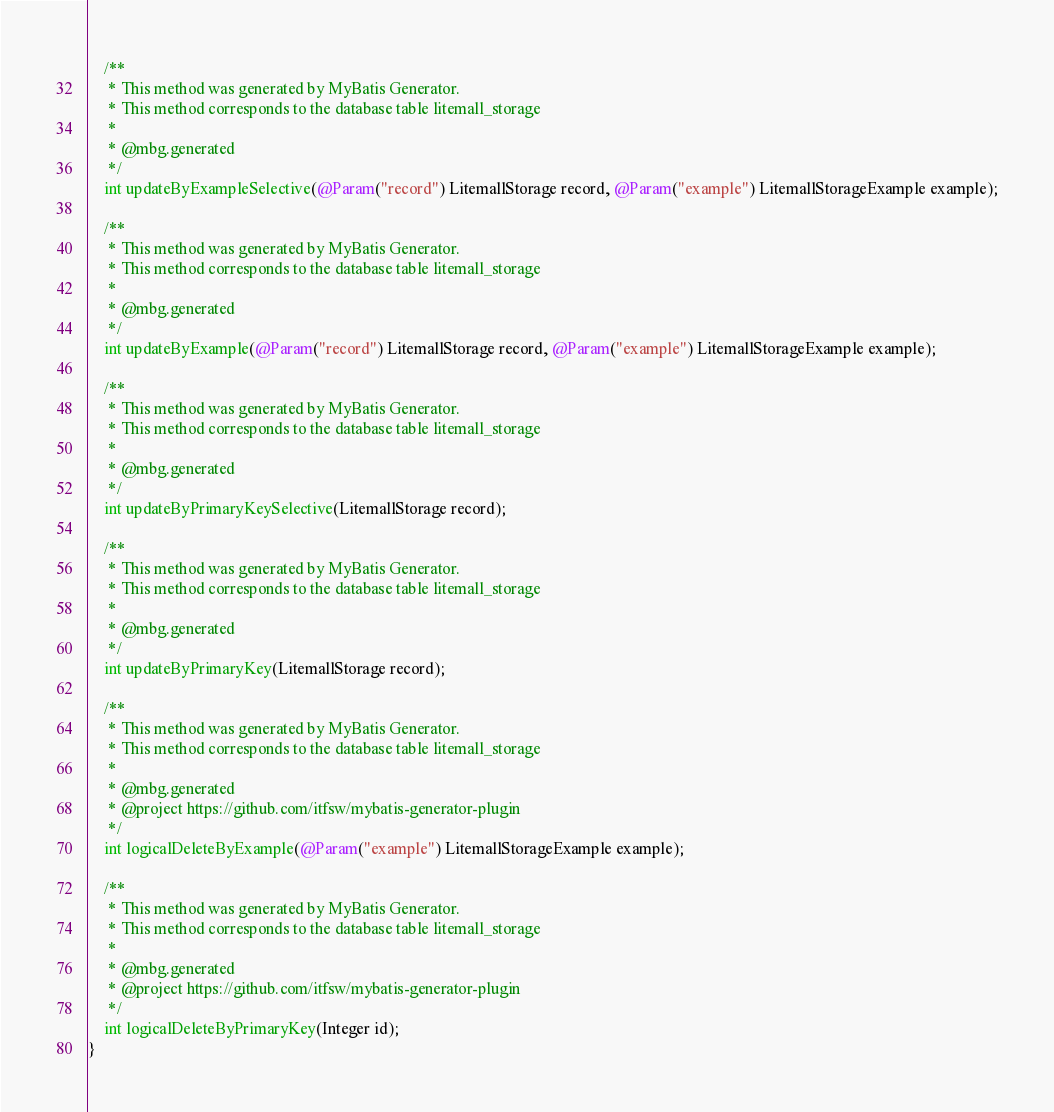<code> <loc_0><loc_0><loc_500><loc_500><_Java_>    /**
     * This method was generated by MyBatis Generator.
     * This method corresponds to the database table litemall_storage
     *
     * @mbg.generated
     */
    int updateByExampleSelective(@Param("record") LitemallStorage record, @Param("example") LitemallStorageExample example);

    /**
     * This method was generated by MyBatis Generator.
     * This method corresponds to the database table litemall_storage
     *
     * @mbg.generated
     */
    int updateByExample(@Param("record") LitemallStorage record, @Param("example") LitemallStorageExample example);

    /**
     * This method was generated by MyBatis Generator.
     * This method corresponds to the database table litemall_storage
     *
     * @mbg.generated
     */
    int updateByPrimaryKeySelective(LitemallStorage record);

    /**
     * This method was generated by MyBatis Generator.
     * This method corresponds to the database table litemall_storage
     *
     * @mbg.generated
     */
    int updateByPrimaryKey(LitemallStorage record);

    /**
     * This method was generated by MyBatis Generator.
     * This method corresponds to the database table litemall_storage
     *
     * @mbg.generated
     * @project https://github.com/itfsw/mybatis-generator-plugin
     */
    int logicalDeleteByExample(@Param("example") LitemallStorageExample example);

    /**
     * This method was generated by MyBatis Generator.
     * This method corresponds to the database table litemall_storage
     *
     * @mbg.generated
     * @project https://github.com/itfsw/mybatis-generator-plugin
     */
    int logicalDeleteByPrimaryKey(Integer id);
}</code> 